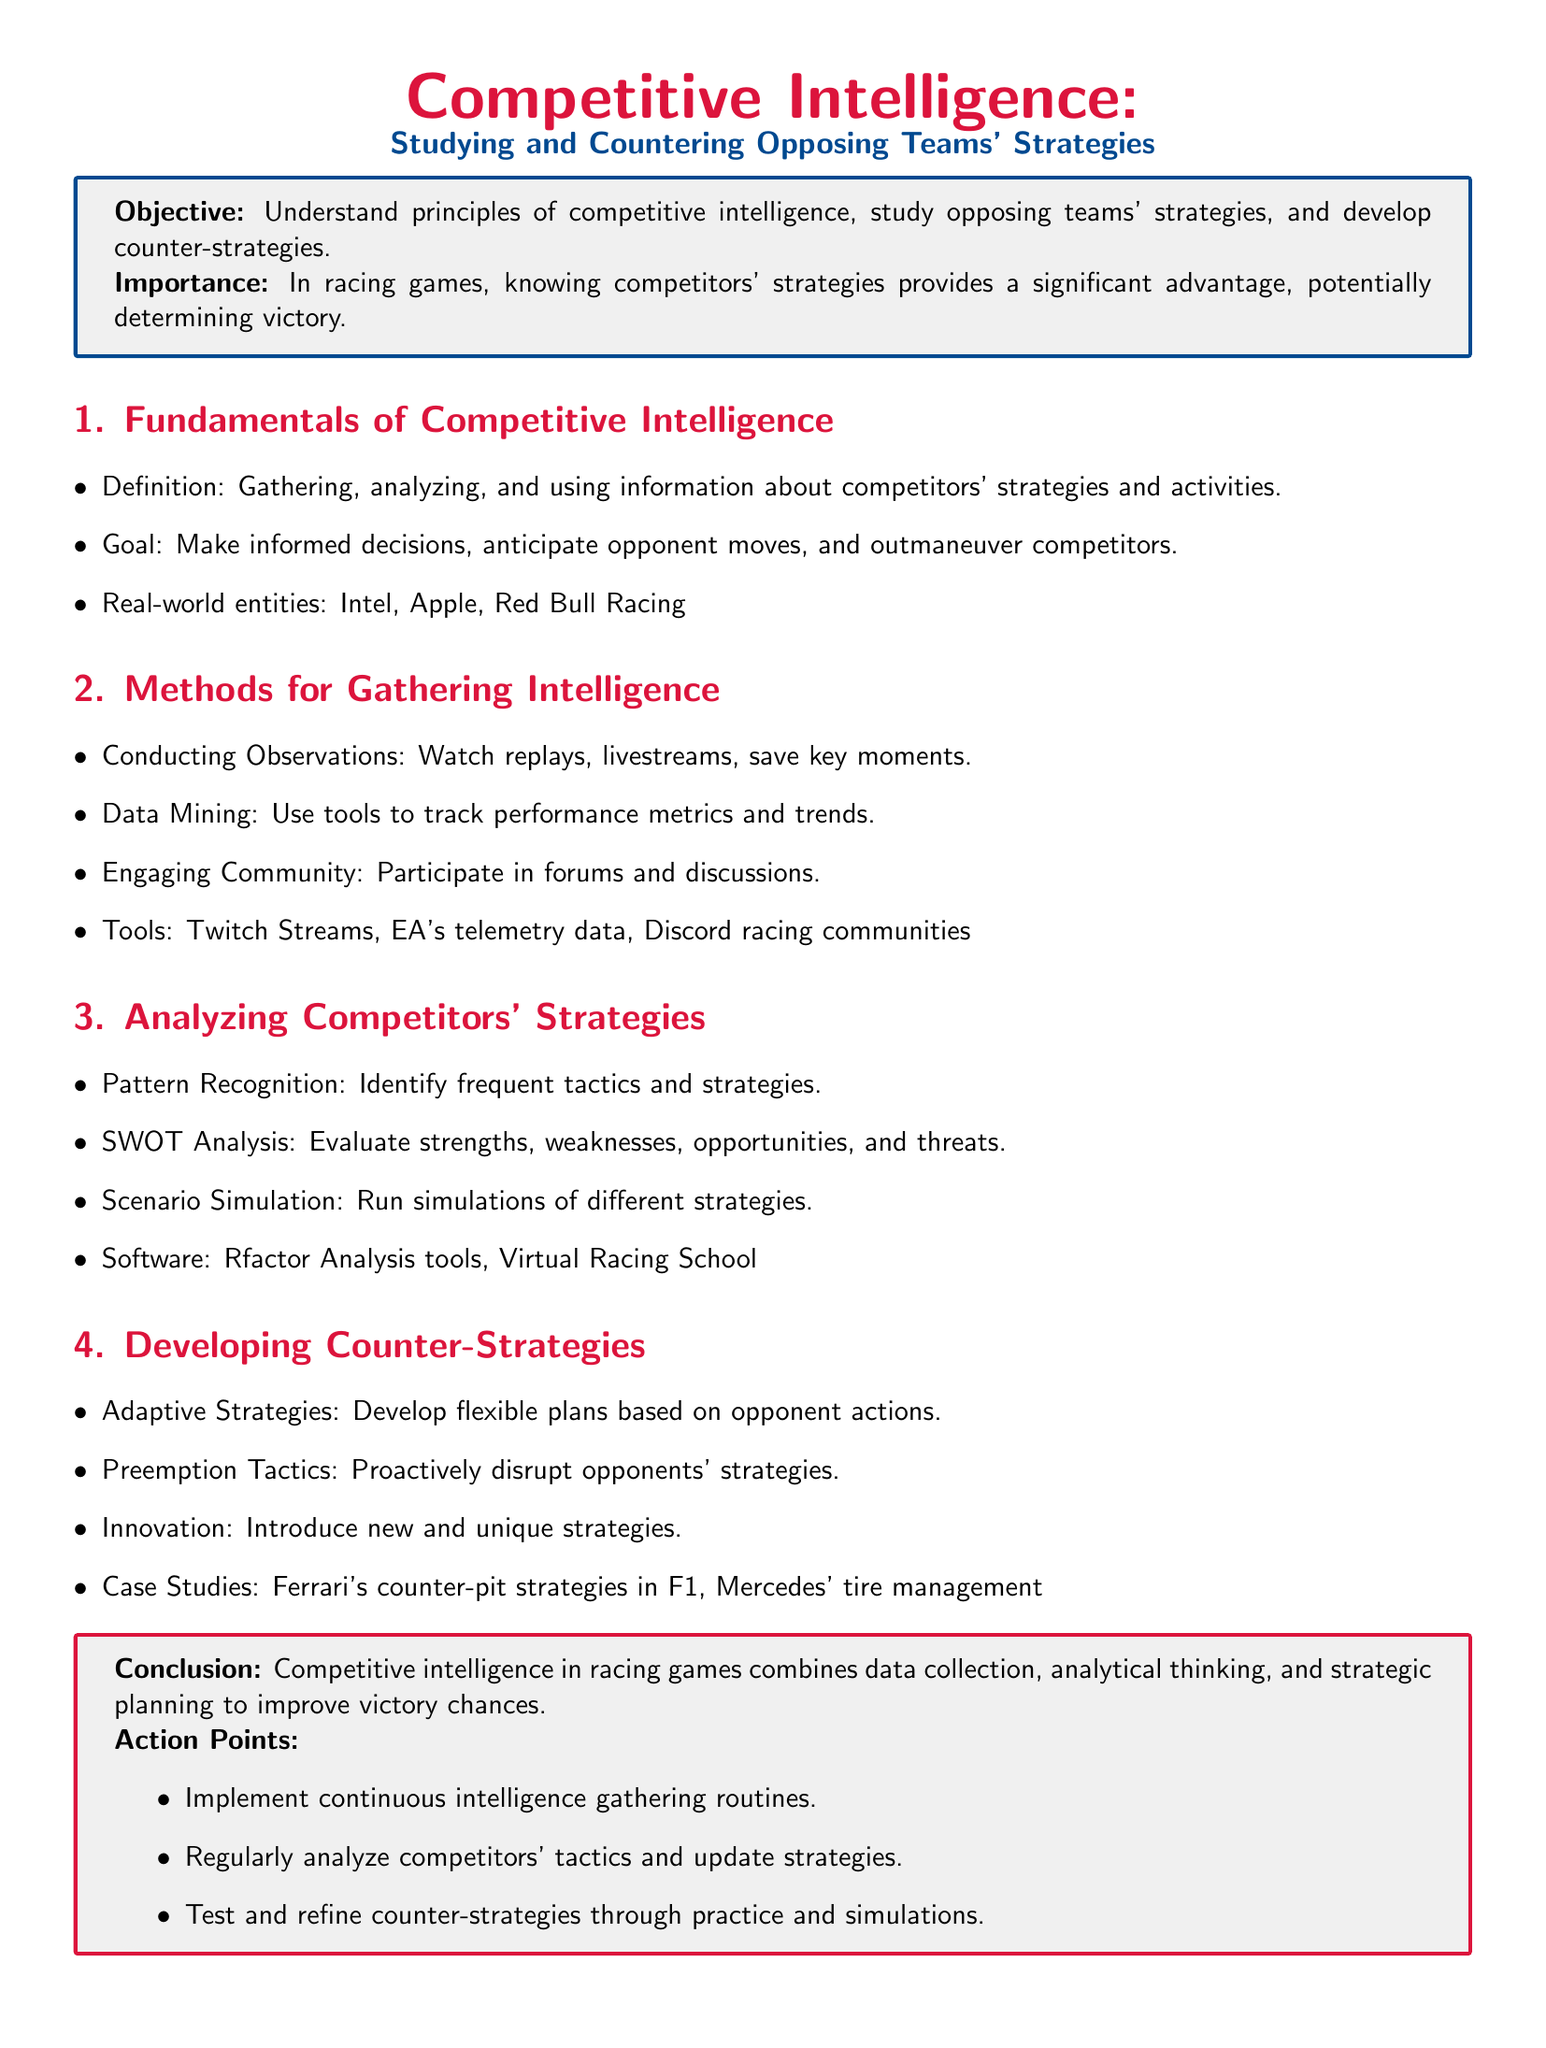What is the main objective of the lesson plan? The objective is to understand principles of competitive intelligence, study opposing teams' strategies, and develop counter-strategies.
Answer: Understand principles of competitive intelligence, study opposing teams' strategies, and develop counter-strategies Which companies are mentioned as real-world entities in competitive intelligence? The document lists Intel, Apple, and Red Bull Racing as examples.
Answer: Intel, Apple, Red Bull Racing What method is suggested for gathering intelligence by engaging with the community? The document mentions participating in forums and discussions as a way to engage with the community.
Answer: Participate in forums and discussions What analysis technique is used to evaluate strengths and weaknesses? The lesson plan refers to SWOT Analysis as the technique for evaluating strengths, weaknesses, opportunities, and threats.
Answer: SWOT Analysis What does the document suggest as a case study for developing counter-strategies? The case study mentioned is Ferrari's counter-pit strategies in F1 and Mercedes' tire management.
Answer: Ferrari's counter-pit strategies in F1, Mercedes' tire management Which software is recommended for analyzing competitors' strategies? The document specifies Rfactor Analysis tools and Virtual Racing School as software for analysis.
Answer: Rfactor Analysis tools, Virtual Racing School What is the concluding statement about competitive intelligence in racing games? The conclusion states that competitive intelligence combines data collection, analytical thinking, and strategic planning to improve victory chances.
Answer: Competitive intelligence combines data collection, analytical thinking, and strategic planning to improve victory chances What are the recommended action points at the end of the document? The action points include implementing continuous intelligence gathering routines, analyzing tactics, and testing counter-strategies.
Answer: Implement continuous intelligence gathering routines, regularly analyze competitors' tactics, test and refine counter-strategies 